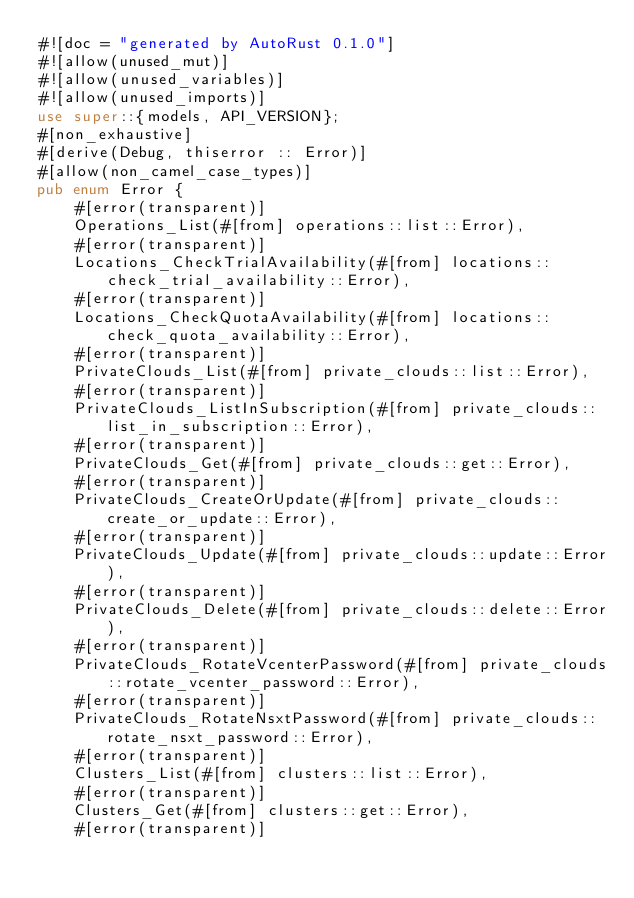<code> <loc_0><loc_0><loc_500><loc_500><_Rust_>#![doc = "generated by AutoRust 0.1.0"]
#![allow(unused_mut)]
#![allow(unused_variables)]
#![allow(unused_imports)]
use super::{models, API_VERSION};
#[non_exhaustive]
#[derive(Debug, thiserror :: Error)]
#[allow(non_camel_case_types)]
pub enum Error {
    #[error(transparent)]
    Operations_List(#[from] operations::list::Error),
    #[error(transparent)]
    Locations_CheckTrialAvailability(#[from] locations::check_trial_availability::Error),
    #[error(transparent)]
    Locations_CheckQuotaAvailability(#[from] locations::check_quota_availability::Error),
    #[error(transparent)]
    PrivateClouds_List(#[from] private_clouds::list::Error),
    #[error(transparent)]
    PrivateClouds_ListInSubscription(#[from] private_clouds::list_in_subscription::Error),
    #[error(transparent)]
    PrivateClouds_Get(#[from] private_clouds::get::Error),
    #[error(transparent)]
    PrivateClouds_CreateOrUpdate(#[from] private_clouds::create_or_update::Error),
    #[error(transparent)]
    PrivateClouds_Update(#[from] private_clouds::update::Error),
    #[error(transparent)]
    PrivateClouds_Delete(#[from] private_clouds::delete::Error),
    #[error(transparent)]
    PrivateClouds_RotateVcenterPassword(#[from] private_clouds::rotate_vcenter_password::Error),
    #[error(transparent)]
    PrivateClouds_RotateNsxtPassword(#[from] private_clouds::rotate_nsxt_password::Error),
    #[error(transparent)]
    Clusters_List(#[from] clusters::list::Error),
    #[error(transparent)]
    Clusters_Get(#[from] clusters::get::Error),
    #[error(transparent)]</code> 